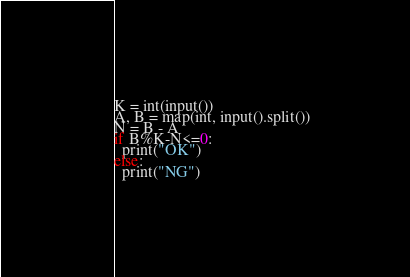<code> <loc_0><loc_0><loc_500><loc_500><_Python_>K = int(input())
A, B = map(int, input().split())
N = B - A
if B%K-N<=0:
  print("OK")
else:
  print("NG")</code> 